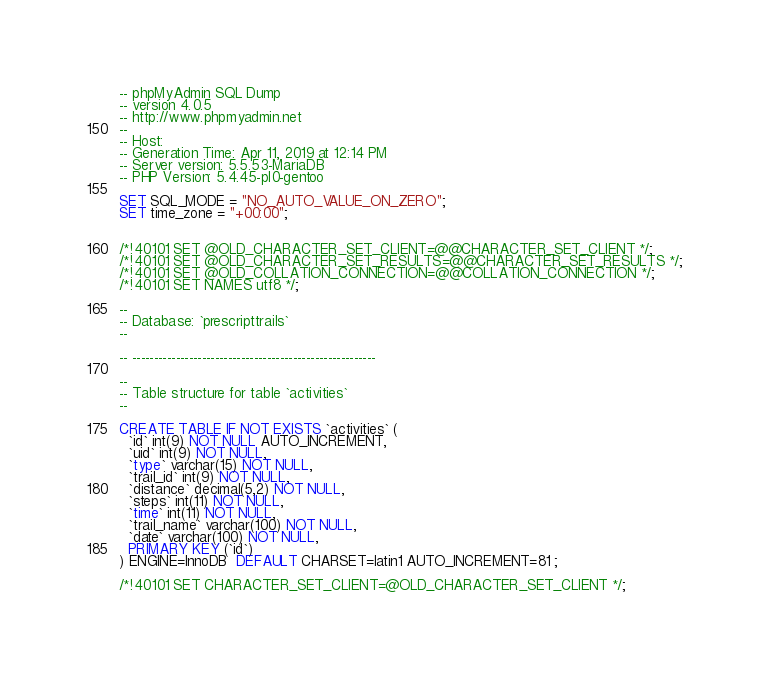<code> <loc_0><loc_0><loc_500><loc_500><_SQL_>-- phpMyAdmin SQL Dump
-- version 4.0.5
-- http://www.phpmyadmin.net
--
-- Host: 
-- Generation Time: Apr 11, 2019 at 12:14 PM
-- Server version: 5.5.53-MariaDB
-- PHP Version: 5.4.45-pl0-gentoo

SET SQL_MODE = "NO_AUTO_VALUE_ON_ZERO";
SET time_zone = "+00:00";


/*!40101 SET @OLD_CHARACTER_SET_CLIENT=@@CHARACTER_SET_CLIENT */;
/*!40101 SET @OLD_CHARACTER_SET_RESULTS=@@CHARACTER_SET_RESULTS */;
/*!40101 SET @OLD_COLLATION_CONNECTION=@@COLLATION_CONNECTION */;
/*!40101 SET NAMES utf8 */;

--
-- Database: `prescripttrails`
--

-- --------------------------------------------------------

--
-- Table structure for table `activities`
--

CREATE TABLE IF NOT EXISTS `activities` (
  `id` int(9) NOT NULL AUTO_INCREMENT,
  `uid` int(9) NOT NULL,
  `type` varchar(15) NOT NULL,
  `trail_id` int(9) NOT NULL,
  `distance` decimal(5,2) NOT NULL,
  `steps` int(11) NOT NULL,
  `time` int(11) NOT NULL,
  `trail_name` varchar(100) NOT NULL,
  `date` varchar(100) NOT NULL,
  PRIMARY KEY (`id`)
) ENGINE=InnoDB  DEFAULT CHARSET=latin1 AUTO_INCREMENT=81 ;

/*!40101 SET CHARACTER_SET_CLIENT=@OLD_CHARACTER_SET_CLIENT */;</code> 